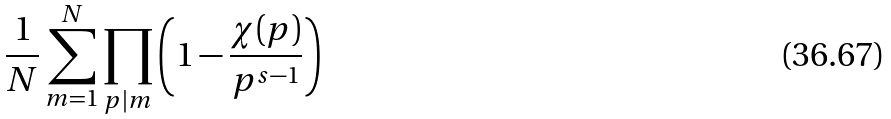<formula> <loc_0><loc_0><loc_500><loc_500>\frac { 1 } { N } \sum _ { m = 1 } ^ { N } \prod _ { p | m } \left ( 1 - \frac { \chi ( p ) } { p ^ { s - 1 } } \right )</formula> 